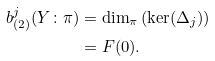<formula> <loc_0><loc_0><loc_500><loc_500>b _ { ( 2 ) } ^ { j } ( Y \colon \pi ) & = \dim _ { \pi } \left ( \ker ( \Delta _ { j } ) \right ) \\ & = F ( 0 ) .</formula> 